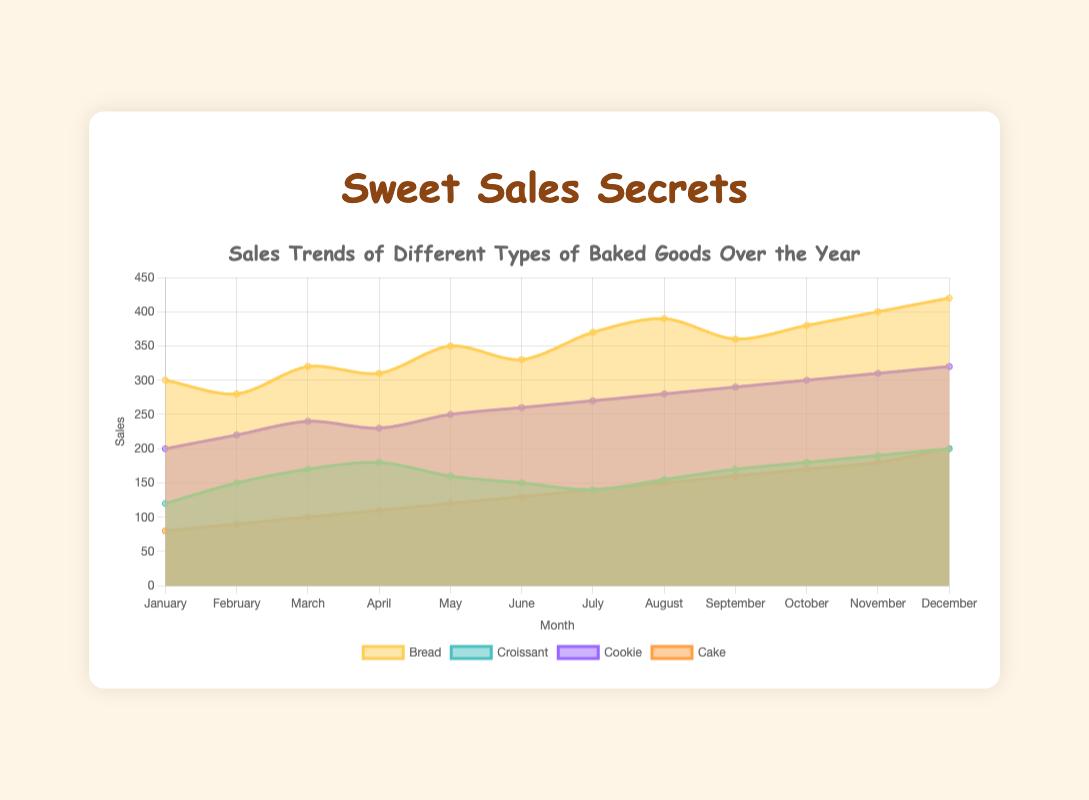What's the title of the chart? The title of the chart is usually displayed at the top. In this case, it is text shown above the chart area.
Answer: Sales Trends of Different Types of Baked Goods Over the Year What is the range of sales for cookies throughout the year? By observing the "Cookie" data in the chart, the lowest value is in January (200), and the highest value is in December (320).
Answer: 200 to 320 How do bread sales in March compare to those in June? Look at the "Bread" sales for March and June specifically. Bread sales are 320 in March and 330 in June.
Answer: Bread sales in June (330) are higher than in March (320) Which month saw the highest sales for cakes? Locate the "Cake" data on the chart and identify the highest point. The highest sales for cakes are in December (200).
Answer: December Are there any months when croissant sales are decreasing compared to the previous month? Check each pair of months for the "Croissant" data. February (150) is higher than January (120), but May (160) is higher than April (180), making June (150) lower than May (160); July (140) also decreases after June.
Answer: June and July What's the combined sales total for cookies and cakes in September? Find the sales figures for both cookies (290) and cakes (160) for September, then add them.
Answer: 450 How much did bread sales increase from November to December? Compare the bread sales in November (400) to December (420) and calculate the difference.
Answer: 20 Which type of baked good experienced the most significant increase in sales from January to December? Determine the increase for each type from January to December: Bread (120), Croissant (80), Cookie (120), Cake (120). Bread, Cookie, and Cake show the same increase but Bread had a higher starting point.
Answer: Bread What was the average monthly sales figure for croissants? Add all the monthly sales figures for croissants (120, 150, 170, 180, 160, 150, 140, 155, 170, 180, 190, 200) and divide by the number of months (12). The sum is 2065, so the average is 2065/12.
Answer: 172 Which baked good had the most stable sales figures over the year? Identify the baked good with the smallest variation in sales figures. Croissants vary from 120 to 200 while others vary more (e.g., Bread ranges from 280 to 420, Cookies 200-320).
Answer: Croissant 